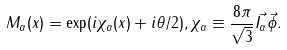<formula> <loc_0><loc_0><loc_500><loc_500>M _ { \alpha } ( x ) = \exp ( i \chi _ { \alpha } ( x ) + i \theta / 2 ) , \chi _ { \alpha } \equiv \frac { 8 \pi } { \sqrt { 3 } } \vec { I _ { \alpha } } \vec { \phi } .</formula> 